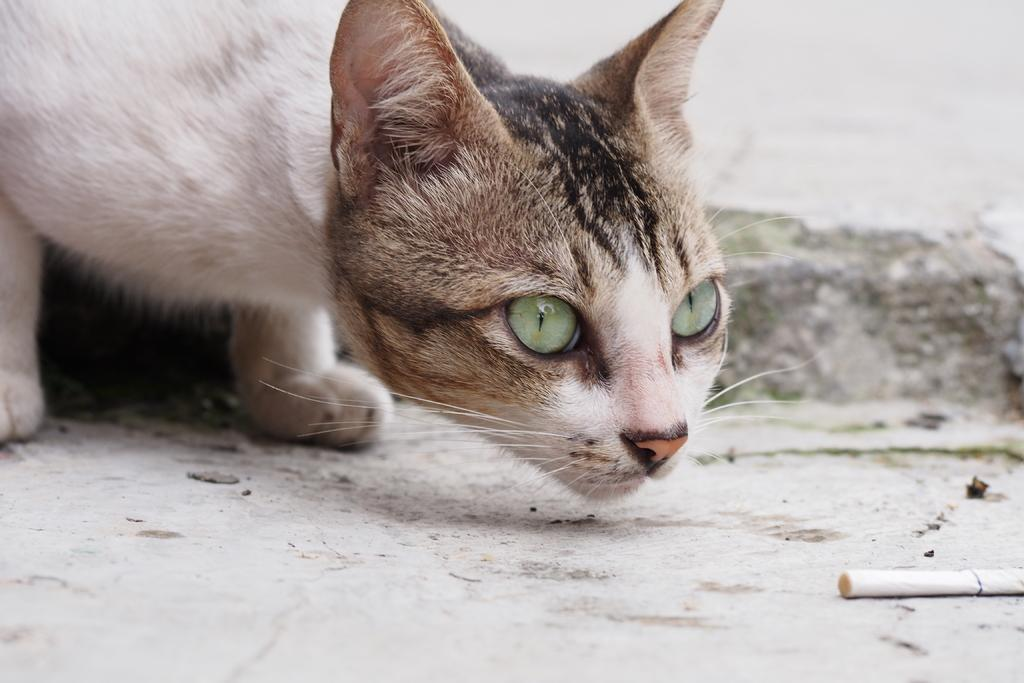What type of animal is present in the image? There is a cat in the image. What object can be seen on the floor in the image? There is a cigarette on the floor in the image. Where is the coat hanging in the image? There is no coat present in the image. What type of landscape can be seen in the image? There is no landscape visible in the image; it only features a cat and a cigarette on the floor. 